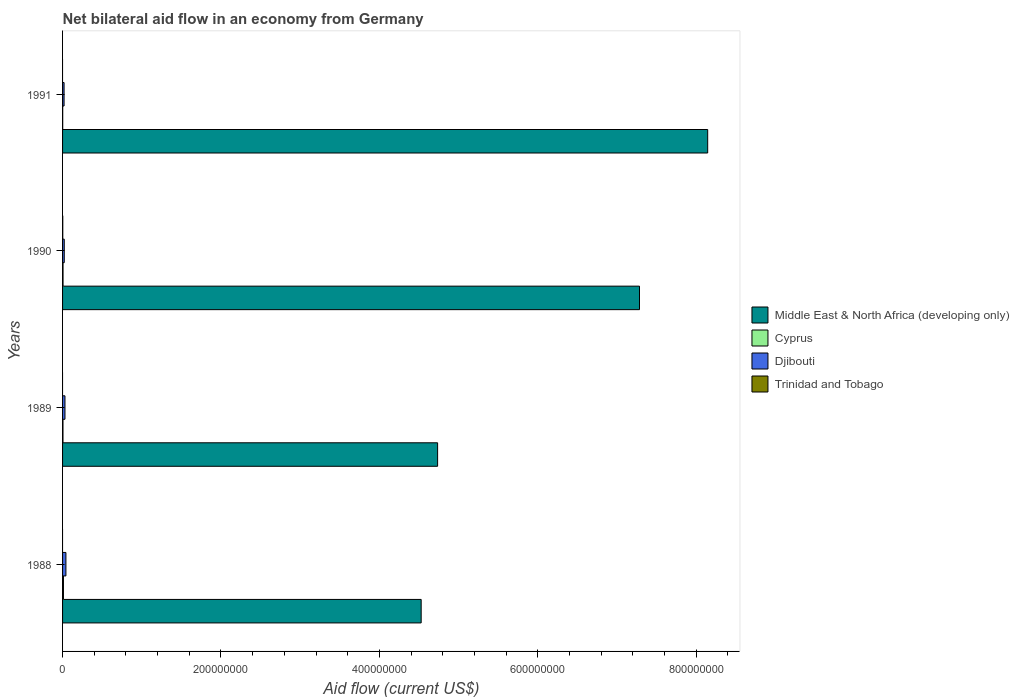How many groups of bars are there?
Keep it short and to the point. 4. Are the number of bars on each tick of the Y-axis equal?
Offer a terse response. No. How many bars are there on the 2nd tick from the bottom?
Provide a short and direct response. 3. What is the label of the 3rd group of bars from the top?
Your answer should be compact. 1989. In how many cases, is the number of bars for a given year not equal to the number of legend labels?
Your response must be concise. 3. What is the net bilateral aid flow in Middle East & North Africa (developing only) in 1991?
Give a very brief answer. 8.14e+08. Across all years, what is the minimum net bilateral aid flow in Trinidad and Tobago?
Your answer should be very brief. 0. In which year was the net bilateral aid flow in Middle East & North Africa (developing only) maximum?
Make the answer very short. 1991. What is the total net bilateral aid flow in Djibouti in the graph?
Offer a very short reply. 1.13e+07. What is the difference between the net bilateral aid flow in Middle East & North Africa (developing only) in 1988 and that in 1990?
Offer a terse response. -2.76e+08. What is the difference between the net bilateral aid flow in Cyprus in 1988 and the net bilateral aid flow in Djibouti in 1989?
Provide a short and direct response. -1.90e+06. In the year 1988, what is the difference between the net bilateral aid flow in Cyprus and net bilateral aid flow in Middle East & North Africa (developing only)?
Ensure brevity in your answer.  -4.52e+08. What is the ratio of the net bilateral aid flow in Cyprus in 1988 to that in 1989?
Offer a terse response. 2.17. Is the net bilateral aid flow in Cyprus in 1990 less than that in 1991?
Keep it short and to the point. No. What is the difference between the highest and the second highest net bilateral aid flow in Djibouti?
Give a very brief answer. 1.21e+06. What is the difference between the highest and the lowest net bilateral aid flow in Cyprus?
Ensure brevity in your answer.  9.50e+05. In how many years, is the net bilateral aid flow in Djibouti greater than the average net bilateral aid flow in Djibouti taken over all years?
Your response must be concise. 2. Is the sum of the net bilateral aid flow in Cyprus in 1990 and 1991 greater than the maximum net bilateral aid flow in Middle East & North Africa (developing only) across all years?
Offer a very short reply. No. How many bars are there?
Offer a very short reply. 13. Are all the bars in the graph horizontal?
Your answer should be very brief. Yes. Does the graph contain grids?
Provide a succinct answer. No. Where does the legend appear in the graph?
Keep it short and to the point. Center right. How many legend labels are there?
Make the answer very short. 4. How are the legend labels stacked?
Give a very brief answer. Vertical. What is the title of the graph?
Ensure brevity in your answer.  Net bilateral aid flow in an economy from Germany. What is the Aid flow (current US$) of Middle East & North Africa (developing only) in 1988?
Ensure brevity in your answer.  4.53e+08. What is the Aid flow (current US$) in Cyprus in 1988?
Keep it short and to the point. 1.13e+06. What is the Aid flow (current US$) of Djibouti in 1988?
Provide a succinct answer. 4.24e+06. What is the Aid flow (current US$) in Middle East & North Africa (developing only) in 1989?
Make the answer very short. 4.74e+08. What is the Aid flow (current US$) in Cyprus in 1989?
Keep it short and to the point. 5.20e+05. What is the Aid flow (current US$) of Djibouti in 1989?
Your answer should be compact. 3.03e+06. What is the Aid flow (current US$) of Trinidad and Tobago in 1989?
Keep it short and to the point. 0. What is the Aid flow (current US$) in Middle East & North Africa (developing only) in 1990?
Keep it short and to the point. 7.28e+08. What is the Aid flow (current US$) of Cyprus in 1990?
Keep it short and to the point. 6.00e+05. What is the Aid flow (current US$) in Djibouti in 1990?
Offer a terse response. 2.14e+06. What is the Aid flow (current US$) of Trinidad and Tobago in 1990?
Your answer should be compact. 2.80e+05. What is the Aid flow (current US$) in Middle East & North Africa (developing only) in 1991?
Your answer should be compact. 8.14e+08. What is the Aid flow (current US$) in Djibouti in 1991?
Give a very brief answer. 1.90e+06. Across all years, what is the maximum Aid flow (current US$) of Middle East & North Africa (developing only)?
Your answer should be very brief. 8.14e+08. Across all years, what is the maximum Aid flow (current US$) of Cyprus?
Provide a short and direct response. 1.13e+06. Across all years, what is the maximum Aid flow (current US$) of Djibouti?
Provide a succinct answer. 4.24e+06. Across all years, what is the minimum Aid flow (current US$) in Middle East & North Africa (developing only)?
Make the answer very short. 4.53e+08. Across all years, what is the minimum Aid flow (current US$) in Djibouti?
Give a very brief answer. 1.90e+06. What is the total Aid flow (current US$) in Middle East & North Africa (developing only) in the graph?
Offer a very short reply. 2.47e+09. What is the total Aid flow (current US$) in Cyprus in the graph?
Your answer should be very brief. 2.43e+06. What is the total Aid flow (current US$) of Djibouti in the graph?
Make the answer very short. 1.13e+07. What is the total Aid flow (current US$) in Trinidad and Tobago in the graph?
Ensure brevity in your answer.  2.80e+05. What is the difference between the Aid flow (current US$) of Middle East & North Africa (developing only) in 1988 and that in 1989?
Your answer should be compact. -2.07e+07. What is the difference between the Aid flow (current US$) of Cyprus in 1988 and that in 1989?
Your response must be concise. 6.10e+05. What is the difference between the Aid flow (current US$) in Djibouti in 1988 and that in 1989?
Provide a short and direct response. 1.21e+06. What is the difference between the Aid flow (current US$) of Middle East & North Africa (developing only) in 1988 and that in 1990?
Ensure brevity in your answer.  -2.76e+08. What is the difference between the Aid flow (current US$) of Cyprus in 1988 and that in 1990?
Your answer should be very brief. 5.30e+05. What is the difference between the Aid flow (current US$) in Djibouti in 1988 and that in 1990?
Ensure brevity in your answer.  2.10e+06. What is the difference between the Aid flow (current US$) of Middle East & North Africa (developing only) in 1988 and that in 1991?
Provide a succinct answer. -3.62e+08. What is the difference between the Aid flow (current US$) of Cyprus in 1988 and that in 1991?
Ensure brevity in your answer.  9.50e+05. What is the difference between the Aid flow (current US$) in Djibouti in 1988 and that in 1991?
Your answer should be very brief. 2.34e+06. What is the difference between the Aid flow (current US$) of Middle East & North Africa (developing only) in 1989 and that in 1990?
Your answer should be very brief. -2.55e+08. What is the difference between the Aid flow (current US$) of Djibouti in 1989 and that in 1990?
Ensure brevity in your answer.  8.90e+05. What is the difference between the Aid flow (current US$) in Middle East & North Africa (developing only) in 1989 and that in 1991?
Your response must be concise. -3.41e+08. What is the difference between the Aid flow (current US$) of Djibouti in 1989 and that in 1991?
Make the answer very short. 1.13e+06. What is the difference between the Aid flow (current US$) of Middle East & North Africa (developing only) in 1990 and that in 1991?
Your answer should be compact. -8.61e+07. What is the difference between the Aid flow (current US$) in Djibouti in 1990 and that in 1991?
Your answer should be very brief. 2.40e+05. What is the difference between the Aid flow (current US$) of Middle East & North Africa (developing only) in 1988 and the Aid flow (current US$) of Cyprus in 1989?
Provide a short and direct response. 4.52e+08. What is the difference between the Aid flow (current US$) in Middle East & North Africa (developing only) in 1988 and the Aid flow (current US$) in Djibouti in 1989?
Provide a short and direct response. 4.50e+08. What is the difference between the Aid flow (current US$) in Cyprus in 1988 and the Aid flow (current US$) in Djibouti in 1989?
Give a very brief answer. -1.90e+06. What is the difference between the Aid flow (current US$) in Middle East & North Africa (developing only) in 1988 and the Aid flow (current US$) in Cyprus in 1990?
Ensure brevity in your answer.  4.52e+08. What is the difference between the Aid flow (current US$) of Middle East & North Africa (developing only) in 1988 and the Aid flow (current US$) of Djibouti in 1990?
Offer a very short reply. 4.51e+08. What is the difference between the Aid flow (current US$) in Middle East & North Africa (developing only) in 1988 and the Aid flow (current US$) in Trinidad and Tobago in 1990?
Keep it short and to the point. 4.52e+08. What is the difference between the Aid flow (current US$) of Cyprus in 1988 and the Aid flow (current US$) of Djibouti in 1990?
Provide a short and direct response. -1.01e+06. What is the difference between the Aid flow (current US$) of Cyprus in 1988 and the Aid flow (current US$) of Trinidad and Tobago in 1990?
Offer a very short reply. 8.50e+05. What is the difference between the Aid flow (current US$) of Djibouti in 1988 and the Aid flow (current US$) of Trinidad and Tobago in 1990?
Provide a short and direct response. 3.96e+06. What is the difference between the Aid flow (current US$) in Middle East & North Africa (developing only) in 1988 and the Aid flow (current US$) in Cyprus in 1991?
Your answer should be very brief. 4.53e+08. What is the difference between the Aid flow (current US$) in Middle East & North Africa (developing only) in 1988 and the Aid flow (current US$) in Djibouti in 1991?
Offer a very short reply. 4.51e+08. What is the difference between the Aid flow (current US$) in Cyprus in 1988 and the Aid flow (current US$) in Djibouti in 1991?
Keep it short and to the point. -7.70e+05. What is the difference between the Aid flow (current US$) of Middle East & North Africa (developing only) in 1989 and the Aid flow (current US$) of Cyprus in 1990?
Your response must be concise. 4.73e+08. What is the difference between the Aid flow (current US$) of Middle East & North Africa (developing only) in 1989 and the Aid flow (current US$) of Djibouti in 1990?
Keep it short and to the point. 4.71e+08. What is the difference between the Aid flow (current US$) in Middle East & North Africa (developing only) in 1989 and the Aid flow (current US$) in Trinidad and Tobago in 1990?
Your answer should be compact. 4.73e+08. What is the difference between the Aid flow (current US$) in Cyprus in 1989 and the Aid flow (current US$) in Djibouti in 1990?
Your response must be concise. -1.62e+06. What is the difference between the Aid flow (current US$) of Djibouti in 1989 and the Aid flow (current US$) of Trinidad and Tobago in 1990?
Give a very brief answer. 2.75e+06. What is the difference between the Aid flow (current US$) of Middle East & North Africa (developing only) in 1989 and the Aid flow (current US$) of Cyprus in 1991?
Give a very brief answer. 4.73e+08. What is the difference between the Aid flow (current US$) of Middle East & North Africa (developing only) in 1989 and the Aid flow (current US$) of Djibouti in 1991?
Provide a short and direct response. 4.72e+08. What is the difference between the Aid flow (current US$) in Cyprus in 1989 and the Aid flow (current US$) in Djibouti in 1991?
Give a very brief answer. -1.38e+06. What is the difference between the Aid flow (current US$) in Middle East & North Africa (developing only) in 1990 and the Aid flow (current US$) in Cyprus in 1991?
Provide a short and direct response. 7.28e+08. What is the difference between the Aid flow (current US$) in Middle East & North Africa (developing only) in 1990 and the Aid flow (current US$) in Djibouti in 1991?
Your answer should be very brief. 7.26e+08. What is the difference between the Aid flow (current US$) in Cyprus in 1990 and the Aid flow (current US$) in Djibouti in 1991?
Your answer should be very brief. -1.30e+06. What is the average Aid flow (current US$) of Middle East & North Africa (developing only) per year?
Keep it short and to the point. 6.17e+08. What is the average Aid flow (current US$) in Cyprus per year?
Provide a succinct answer. 6.08e+05. What is the average Aid flow (current US$) of Djibouti per year?
Make the answer very short. 2.83e+06. In the year 1988, what is the difference between the Aid flow (current US$) of Middle East & North Africa (developing only) and Aid flow (current US$) of Cyprus?
Your answer should be compact. 4.52e+08. In the year 1988, what is the difference between the Aid flow (current US$) of Middle East & North Africa (developing only) and Aid flow (current US$) of Djibouti?
Provide a succinct answer. 4.49e+08. In the year 1988, what is the difference between the Aid flow (current US$) of Cyprus and Aid flow (current US$) of Djibouti?
Provide a succinct answer. -3.11e+06. In the year 1989, what is the difference between the Aid flow (current US$) in Middle East & North Africa (developing only) and Aid flow (current US$) in Cyprus?
Offer a very short reply. 4.73e+08. In the year 1989, what is the difference between the Aid flow (current US$) in Middle East & North Africa (developing only) and Aid flow (current US$) in Djibouti?
Your response must be concise. 4.70e+08. In the year 1989, what is the difference between the Aid flow (current US$) of Cyprus and Aid flow (current US$) of Djibouti?
Provide a short and direct response. -2.51e+06. In the year 1990, what is the difference between the Aid flow (current US$) of Middle East & North Africa (developing only) and Aid flow (current US$) of Cyprus?
Give a very brief answer. 7.28e+08. In the year 1990, what is the difference between the Aid flow (current US$) in Middle East & North Africa (developing only) and Aid flow (current US$) in Djibouti?
Your response must be concise. 7.26e+08. In the year 1990, what is the difference between the Aid flow (current US$) of Middle East & North Africa (developing only) and Aid flow (current US$) of Trinidad and Tobago?
Provide a succinct answer. 7.28e+08. In the year 1990, what is the difference between the Aid flow (current US$) in Cyprus and Aid flow (current US$) in Djibouti?
Provide a short and direct response. -1.54e+06. In the year 1990, what is the difference between the Aid flow (current US$) in Djibouti and Aid flow (current US$) in Trinidad and Tobago?
Give a very brief answer. 1.86e+06. In the year 1991, what is the difference between the Aid flow (current US$) in Middle East & North Africa (developing only) and Aid flow (current US$) in Cyprus?
Offer a terse response. 8.14e+08. In the year 1991, what is the difference between the Aid flow (current US$) in Middle East & North Africa (developing only) and Aid flow (current US$) in Djibouti?
Offer a terse response. 8.13e+08. In the year 1991, what is the difference between the Aid flow (current US$) in Cyprus and Aid flow (current US$) in Djibouti?
Keep it short and to the point. -1.72e+06. What is the ratio of the Aid flow (current US$) of Middle East & North Africa (developing only) in 1988 to that in 1989?
Make the answer very short. 0.96. What is the ratio of the Aid flow (current US$) of Cyprus in 1988 to that in 1989?
Your answer should be compact. 2.17. What is the ratio of the Aid flow (current US$) of Djibouti in 1988 to that in 1989?
Give a very brief answer. 1.4. What is the ratio of the Aid flow (current US$) of Middle East & North Africa (developing only) in 1988 to that in 1990?
Offer a terse response. 0.62. What is the ratio of the Aid flow (current US$) of Cyprus in 1988 to that in 1990?
Ensure brevity in your answer.  1.88. What is the ratio of the Aid flow (current US$) of Djibouti in 1988 to that in 1990?
Make the answer very short. 1.98. What is the ratio of the Aid flow (current US$) in Middle East & North Africa (developing only) in 1988 to that in 1991?
Provide a succinct answer. 0.56. What is the ratio of the Aid flow (current US$) of Cyprus in 1988 to that in 1991?
Provide a short and direct response. 6.28. What is the ratio of the Aid flow (current US$) in Djibouti in 1988 to that in 1991?
Make the answer very short. 2.23. What is the ratio of the Aid flow (current US$) in Middle East & North Africa (developing only) in 1989 to that in 1990?
Provide a succinct answer. 0.65. What is the ratio of the Aid flow (current US$) of Cyprus in 1989 to that in 1990?
Make the answer very short. 0.87. What is the ratio of the Aid flow (current US$) in Djibouti in 1989 to that in 1990?
Make the answer very short. 1.42. What is the ratio of the Aid flow (current US$) of Middle East & North Africa (developing only) in 1989 to that in 1991?
Ensure brevity in your answer.  0.58. What is the ratio of the Aid flow (current US$) in Cyprus in 1989 to that in 1991?
Your answer should be compact. 2.89. What is the ratio of the Aid flow (current US$) of Djibouti in 1989 to that in 1991?
Keep it short and to the point. 1.59. What is the ratio of the Aid flow (current US$) of Middle East & North Africa (developing only) in 1990 to that in 1991?
Give a very brief answer. 0.89. What is the ratio of the Aid flow (current US$) in Cyprus in 1990 to that in 1991?
Ensure brevity in your answer.  3.33. What is the ratio of the Aid flow (current US$) of Djibouti in 1990 to that in 1991?
Your answer should be very brief. 1.13. What is the difference between the highest and the second highest Aid flow (current US$) in Middle East & North Africa (developing only)?
Give a very brief answer. 8.61e+07. What is the difference between the highest and the second highest Aid flow (current US$) of Cyprus?
Your answer should be very brief. 5.30e+05. What is the difference between the highest and the second highest Aid flow (current US$) in Djibouti?
Provide a short and direct response. 1.21e+06. What is the difference between the highest and the lowest Aid flow (current US$) of Middle East & North Africa (developing only)?
Your response must be concise. 3.62e+08. What is the difference between the highest and the lowest Aid flow (current US$) of Cyprus?
Your answer should be compact. 9.50e+05. What is the difference between the highest and the lowest Aid flow (current US$) in Djibouti?
Ensure brevity in your answer.  2.34e+06. What is the difference between the highest and the lowest Aid flow (current US$) of Trinidad and Tobago?
Your answer should be very brief. 2.80e+05. 